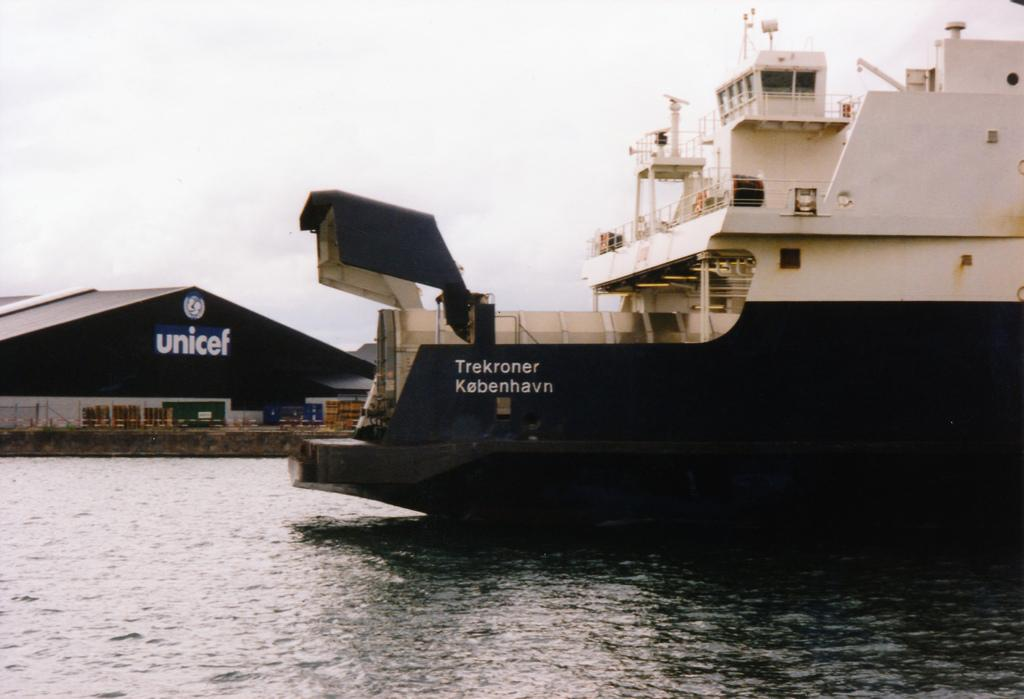<image>
Summarize the visual content of the image. A boat is on the water in front of a building that has unicef on the sign. 